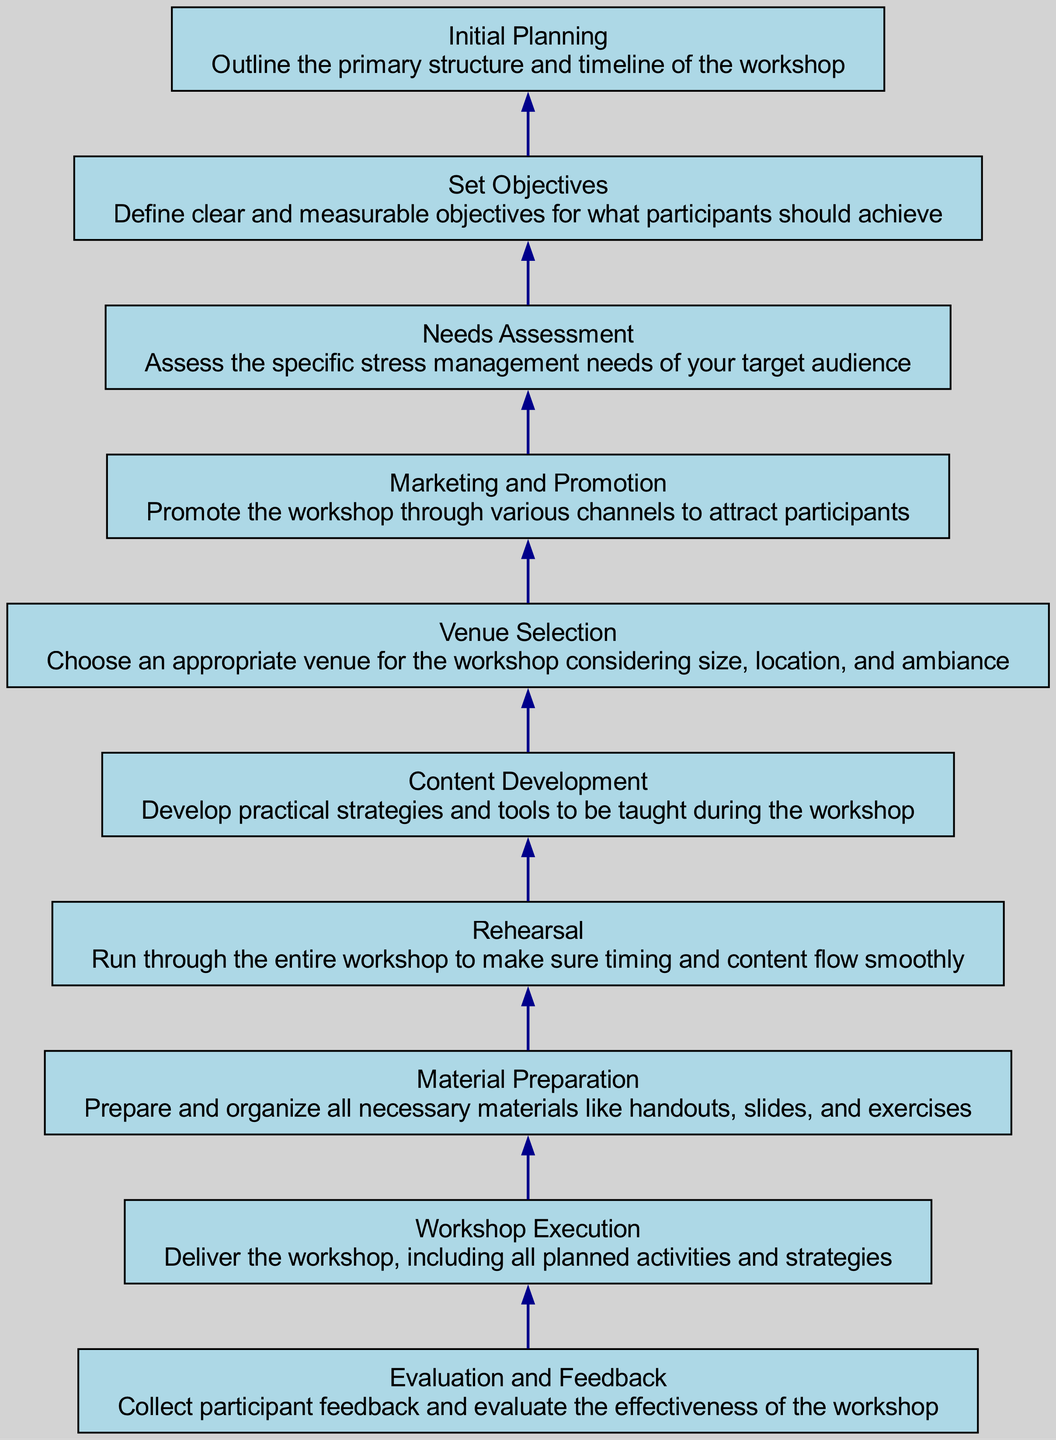What is the topmost step in the flow chart? The topmost step represents the final action in the workflow, which is "Evaluation and Feedback." This is determined by looking at the last node in the diagram as it is rendered from bottom to top.
Answer: Evaluation and Feedback How many nodes are there in the flow chart? Counting each distinct action or step in the diagram gives a total of ten nodes. This is determined by reviewing each labeled box representing a unique task in the flow chart.
Answer: 10 What precedes "Workshop Execution" in the flow chart? The step that comes immediately before "Workshop Execution" is "Material Preparation." This can be confirmed by looking for the node that directly connects to it below in the flow chart.
Answer: Material Preparation What step is directly after "Needs Assessment"? The step that follows "Needs Assessment" is "Set Objectives." This is confirmed by following the connection upwards from the "Needs Assessment" node.
Answer: Set Objectives Which step focuses on creating content for the workshop? The step that pertains to creating content is "Content Development." This can be found in the flow chart as the node directly responsible for developing the workshop materials prior to execution.
Answer: Content Development What is the relationship between "Marketing and Promotion" and "Venue Selection"? "Marketing and Promotion" flows upwards to "Venue Selection," indicating it is a prerequisite before selecting a venue. This can be inferred by the direct edge from "Marketing and Promotion" to "Venue Selection" along the path.
Answer: Marketing and Promotion leads to Venue Selection Which step has the primary focus on the timeline of the workshop? The step that outlines the primary structure and timeline is "Initial Planning." This node indicates the scheduling aspect prior to further actions. Therefore, it is specifically responsible for planning the timeline.
Answer: Initial Planning What part of the flow chart deals with assessing the audience's needs? The section of the flow chart that is focused on assessing the audience's needs is "Needs Assessment." This is discerned by finding the node that specifically mentions evaluating target audience requirements.
Answer: Needs Assessment What is the second step in the flow chart? The second step, as counted from the top down, is "Workshop Execution." This positioning can be confirmed by identifying the connections and order of operations shown in the diagram.
Answer: Workshop Execution What is the last step before "Evaluation and Feedback"? The last step before "Evaluation and Feedback" is "Workshop Execution." This is determined by observing the direct flow leading down to the final evaluation stage before wrapping up the process.
Answer: Workshop Execution 